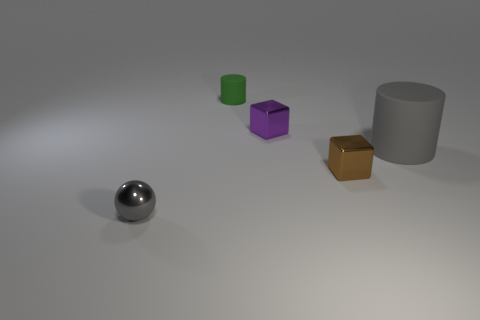Add 4 green cylinders. How many objects exist? 9 Subtract all cylinders. How many objects are left? 3 Subtract 0 green cubes. How many objects are left? 5 Subtract all small purple blocks. Subtract all big gray rubber cylinders. How many objects are left? 3 Add 5 green rubber cylinders. How many green rubber cylinders are left? 6 Add 5 large brown rubber balls. How many large brown rubber balls exist? 5 